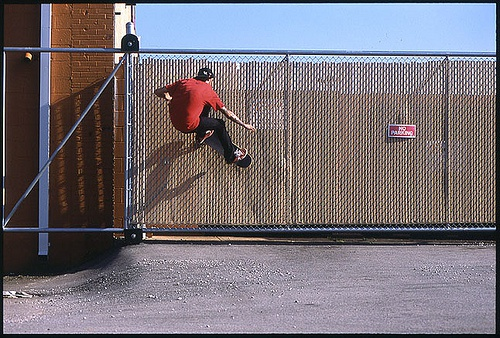Describe the objects in this image and their specific colors. I can see people in black, maroon, salmon, and brown tones and skateboard in black, gray, and beige tones in this image. 